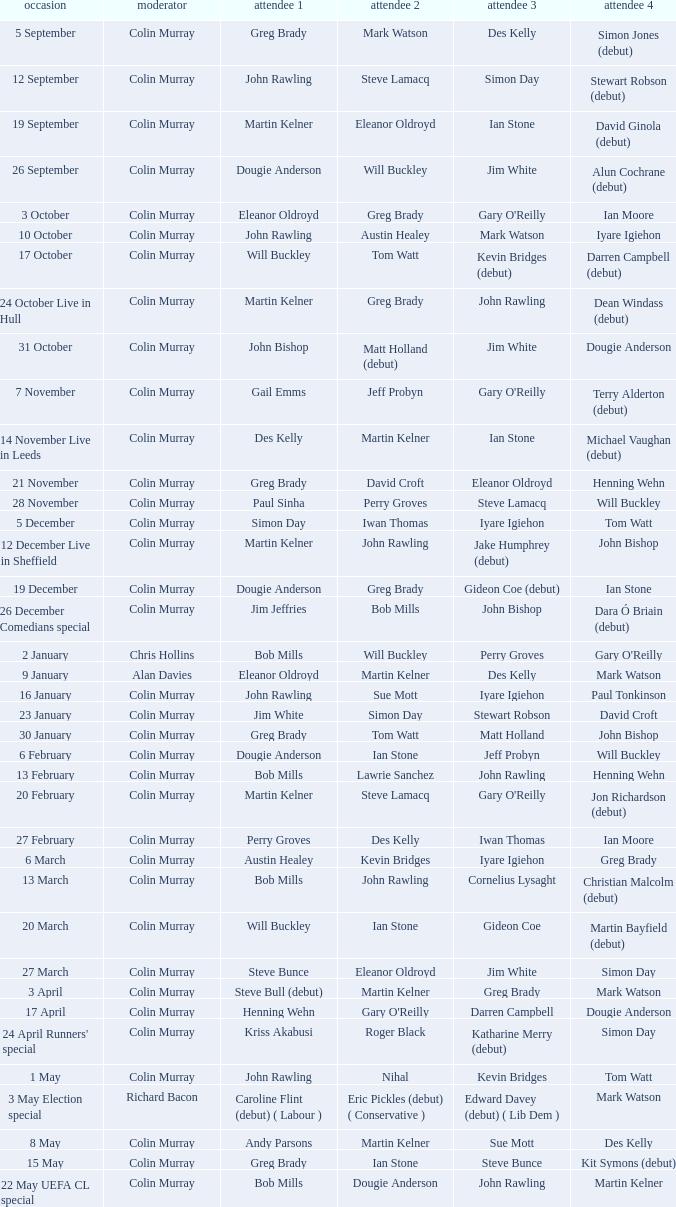How many people are guest 1 on episodes where guest 4 is Des Kelly? 1.0. 